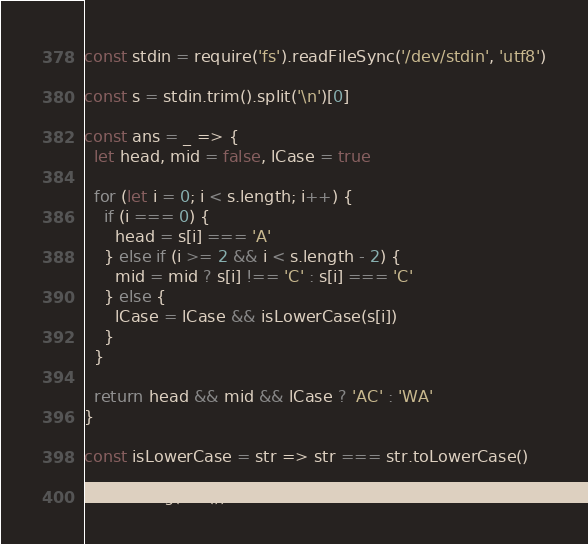<code> <loc_0><loc_0><loc_500><loc_500><_TypeScript_>const stdin = require('fs').readFileSync('/dev/stdin', 'utf8')

const s = stdin.trim().split('\n')[0]

const ans = _ => {
  let head, mid = false, lCase = true

  for (let i = 0; i < s.length; i++) {
    if (i === 0) {
      head = s[i] === 'A'
    } else if (i >= 2 && i < s.length - 2) {
      mid = mid ? s[i] !== 'C' : s[i] === 'C'
    } else {
      lCase = lCase && isLowerCase(s[i])
    }
  }

  return head && mid && lCase ? 'AC' : 'WA'
}

const isLowerCase = str => str === str.toLowerCase()

console.log(ans())
</code> 